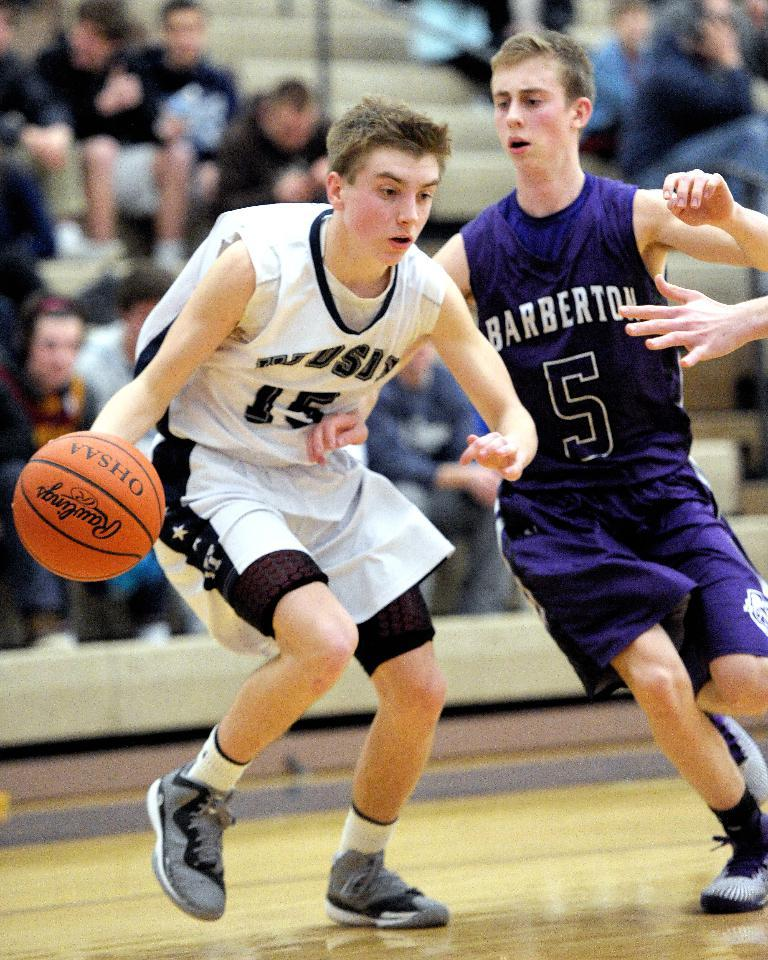What are the two persons in the image doing? Two persons are playing basketball in the image. Can you describe the people in the background? There are people sitting and watching in the background. How is the background of the image depicted? The background of the image is blurred. What type of motion can be seen in the image as the ball is smashed by the players? There is no ball being smashed in the image; the two persons are playing basketball, but the ball is not depicted as being smashed. 